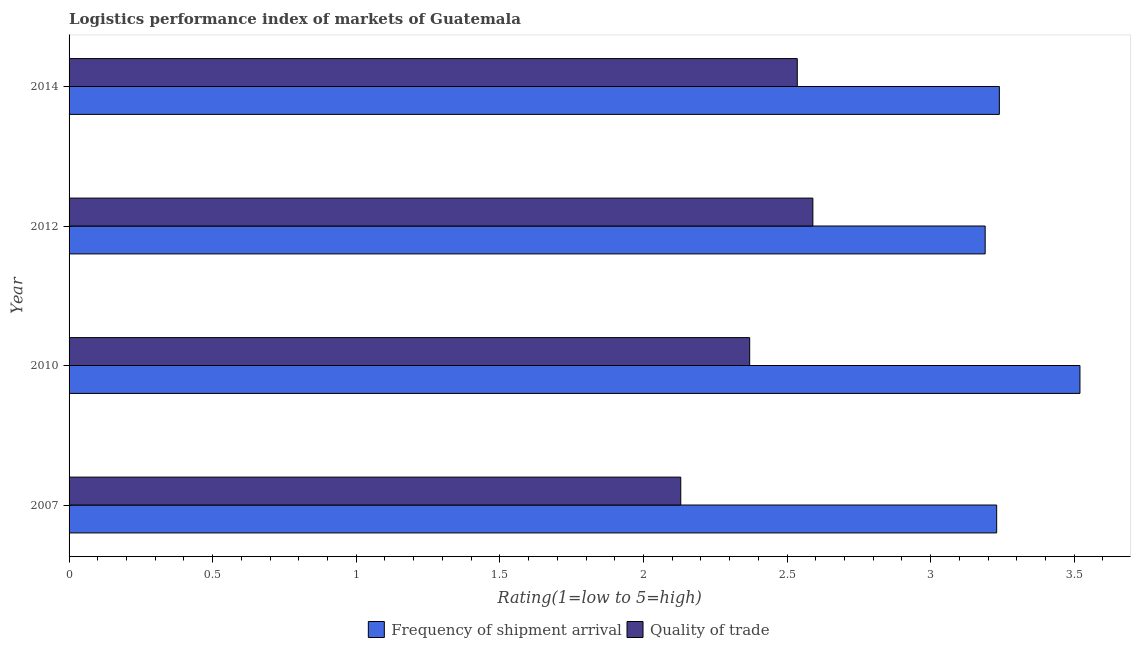How many different coloured bars are there?
Your answer should be compact. 2. Are the number of bars on each tick of the Y-axis equal?
Offer a terse response. Yes. How many bars are there on the 2nd tick from the top?
Keep it short and to the point. 2. What is the label of the 4th group of bars from the top?
Ensure brevity in your answer.  2007. In how many cases, is the number of bars for a given year not equal to the number of legend labels?
Provide a short and direct response. 0. What is the lpi quality of trade in 2012?
Your answer should be very brief. 2.59. Across all years, what is the maximum lpi quality of trade?
Offer a terse response. 2.59. Across all years, what is the minimum lpi of frequency of shipment arrival?
Keep it short and to the point. 3.19. In which year was the lpi of frequency of shipment arrival maximum?
Provide a succinct answer. 2010. What is the total lpi quality of trade in the graph?
Your answer should be compact. 9.63. What is the difference between the lpi quality of trade in 2010 and that in 2014?
Your response must be concise. -0.17. What is the difference between the lpi quality of trade in 2010 and the lpi of frequency of shipment arrival in 2012?
Your answer should be very brief. -0.82. What is the average lpi quality of trade per year?
Offer a very short reply. 2.41. In the year 2012, what is the difference between the lpi of frequency of shipment arrival and lpi quality of trade?
Keep it short and to the point. 0.6. In how many years, is the lpi quality of trade greater than 1.5 ?
Make the answer very short. 4. Is the lpi of frequency of shipment arrival in 2007 less than that in 2012?
Ensure brevity in your answer.  No. What is the difference between the highest and the second highest lpi of frequency of shipment arrival?
Ensure brevity in your answer.  0.28. What is the difference between the highest and the lowest lpi quality of trade?
Provide a short and direct response. 0.46. In how many years, is the lpi of frequency of shipment arrival greater than the average lpi of frequency of shipment arrival taken over all years?
Ensure brevity in your answer.  1. Is the sum of the lpi quality of trade in 2007 and 2012 greater than the maximum lpi of frequency of shipment arrival across all years?
Give a very brief answer. Yes. What does the 2nd bar from the top in 2010 represents?
Provide a short and direct response. Frequency of shipment arrival. What does the 1st bar from the bottom in 2014 represents?
Make the answer very short. Frequency of shipment arrival. Are all the bars in the graph horizontal?
Your answer should be compact. Yes. How many years are there in the graph?
Offer a very short reply. 4. Are the values on the major ticks of X-axis written in scientific E-notation?
Provide a succinct answer. No. Does the graph contain grids?
Give a very brief answer. No. Where does the legend appear in the graph?
Provide a short and direct response. Bottom center. How many legend labels are there?
Give a very brief answer. 2. How are the legend labels stacked?
Your response must be concise. Horizontal. What is the title of the graph?
Ensure brevity in your answer.  Logistics performance index of markets of Guatemala. What is the label or title of the X-axis?
Your answer should be compact. Rating(1=low to 5=high). What is the Rating(1=low to 5=high) of Frequency of shipment arrival in 2007?
Give a very brief answer. 3.23. What is the Rating(1=low to 5=high) of Quality of trade in 2007?
Give a very brief answer. 2.13. What is the Rating(1=low to 5=high) of Frequency of shipment arrival in 2010?
Make the answer very short. 3.52. What is the Rating(1=low to 5=high) of Quality of trade in 2010?
Provide a short and direct response. 2.37. What is the Rating(1=low to 5=high) of Frequency of shipment arrival in 2012?
Your answer should be very brief. 3.19. What is the Rating(1=low to 5=high) of Quality of trade in 2012?
Offer a terse response. 2.59. What is the Rating(1=low to 5=high) in Frequency of shipment arrival in 2014?
Make the answer very short. 3.24. What is the Rating(1=low to 5=high) in Quality of trade in 2014?
Provide a short and direct response. 2.54. Across all years, what is the maximum Rating(1=low to 5=high) in Frequency of shipment arrival?
Keep it short and to the point. 3.52. Across all years, what is the maximum Rating(1=low to 5=high) of Quality of trade?
Keep it short and to the point. 2.59. Across all years, what is the minimum Rating(1=low to 5=high) in Frequency of shipment arrival?
Provide a short and direct response. 3.19. Across all years, what is the minimum Rating(1=low to 5=high) of Quality of trade?
Ensure brevity in your answer.  2.13. What is the total Rating(1=low to 5=high) in Frequency of shipment arrival in the graph?
Give a very brief answer. 13.18. What is the total Rating(1=low to 5=high) in Quality of trade in the graph?
Offer a terse response. 9.63. What is the difference between the Rating(1=low to 5=high) in Frequency of shipment arrival in 2007 and that in 2010?
Your answer should be very brief. -0.29. What is the difference between the Rating(1=low to 5=high) of Quality of trade in 2007 and that in 2010?
Provide a succinct answer. -0.24. What is the difference between the Rating(1=low to 5=high) of Quality of trade in 2007 and that in 2012?
Your response must be concise. -0.46. What is the difference between the Rating(1=low to 5=high) in Frequency of shipment arrival in 2007 and that in 2014?
Make the answer very short. -0.01. What is the difference between the Rating(1=low to 5=high) in Quality of trade in 2007 and that in 2014?
Offer a terse response. -0.41. What is the difference between the Rating(1=low to 5=high) in Frequency of shipment arrival in 2010 and that in 2012?
Provide a succinct answer. 0.33. What is the difference between the Rating(1=low to 5=high) in Quality of trade in 2010 and that in 2012?
Give a very brief answer. -0.22. What is the difference between the Rating(1=low to 5=high) in Frequency of shipment arrival in 2010 and that in 2014?
Provide a succinct answer. 0.28. What is the difference between the Rating(1=low to 5=high) in Quality of trade in 2010 and that in 2014?
Keep it short and to the point. -0.17. What is the difference between the Rating(1=low to 5=high) in Frequency of shipment arrival in 2012 and that in 2014?
Provide a short and direct response. -0.05. What is the difference between the Rating(1=low to 5=high) in Quality of trade in 2012 and that in 2014?
Give a very brief answer. 0.05. What is the difference between the Rating(1=low to 5=high) of Frequency of shipment arrival in 2007 and the Rating(1=low to 5=high) of Quality of trade in 2010?
Your answer should be compact. 0.86. What is the difference between the Rating(1=low to 5=high) in Frequency of shipment arrival in 2007 and the Rating(1=low to 5=high) in Quality of trade in 2012?
Your answer should be compact. 0.64. What is the difference between the Rating(1=low to 5=high) in Frequency of shipment arrival in 2007 and the Rating(1=low to 5=high) in Quality of trade in 2014?
Provide a succinct answer. 0.69. What is the difference between the Rating(1=low to 5=high) of Frequency of shipment arrival in 2010 and the Rating(1=low to 5=high) of Quality of trade in 2014?
Your answer should be compact. 0.98. What is the difference between the Rating(1=low to 5=high) of Frequency of shipment arrival in 2012 and the Rating(1=low to 5=high) of Quality of trade in 2014?
Provide a succinct answer. 0.65. What is the average Rating(1=low to 5=high) of Frequency of shipment arrival per year?
Offer a terse response. 3.29. What is the average Rating(1=low to 5=high) in Quality of trade per year?
Offer a terse response. 2.41. In the year 2010, what is the difference between the Rating(1=low to 5=high) in Frequency of shipment arrival and Rating(1=low to 5=high) in Quality of trade?
Keep it short and to the point. 1.15. In the year 2014, what is the difference between the Rating(1=low to 5=high) of Frequency of shipment arrival and Rating(1=low to 5=high) of Quality of trade?
Keep it short and to the point. 0.7. What is the ratio of the Rating(1=low to 5=high) in Frequency of shipment arrival in 2007 to that in 2010?
Provide a short and direct response. 0.92. What is the ratio of the Rating(1=low to 5=high) of Quality of trade in 2007 to that in 2010?
Ensure brevity in your answer.  0.9. What is the ratio of the Rating(1=low to 5=high) in Frequency of shipment arrival in 2007 to that in 2012?
Your answer should be compact. 1.01. What is the ratio of the Rating(1=low to 5=high) in Quality of trade in 2007 to that in 2012?
Make the answer very short. 0.82. What is the ratio of the Rating(1=low to 5=high) in Frequency of shipment arrival in 2007 to that in 2014?
Provide a short and direct response. 1. What is the ratio of the Rating(1=low to 5=high) in Quality of trade in 2007 to that in 2014?
Provide a short and direct response. 0.84. What is the ratio of the Rating(1=low to 5=high) of Frequency of shipment arrival in 2010 to that in 2012?
Your answer should be very brief. 1.1. What is the ratio of the Rating(1=low to 5=high) in Quality of trade in 2010 to that in 2012?
Provide a short and direct response. 0.92. What is the ratio of the Rating(1=low to 5=high) of Frequency of shipment arrival in 2010 to that in 2014?
Give a very brief answer. 1.09. What is the ratio of the Rating(1=low to 5=high) in Quality of trade in 2010 to that in 2014?
Offer a terse response. 0.93. What is the ratio of the Rating(1=low to 5=high) of Quality of trade in 2012 to that in 2014?
Offer a very short reply. 1.02. What is the difference between the highest and the second highest Rating(1=low to 5=high) in Frequency of shipment arrival?
Make the answer very short. 0.28. What is the difference between the highest and the second highest Rating(1=low to 5=high) of Quality of trade?
Make the answer very short. 0.05. What is the difference between the highest and the lowest Rating(1=low to 5=high) in Frequency of shipment arrival?
Make the answer very short. 0.33. What is the difference between the highest and the lowest Rating(1=low to 5=high) in Quality of trade?
Ensure brevity in your answer.  0.46. 